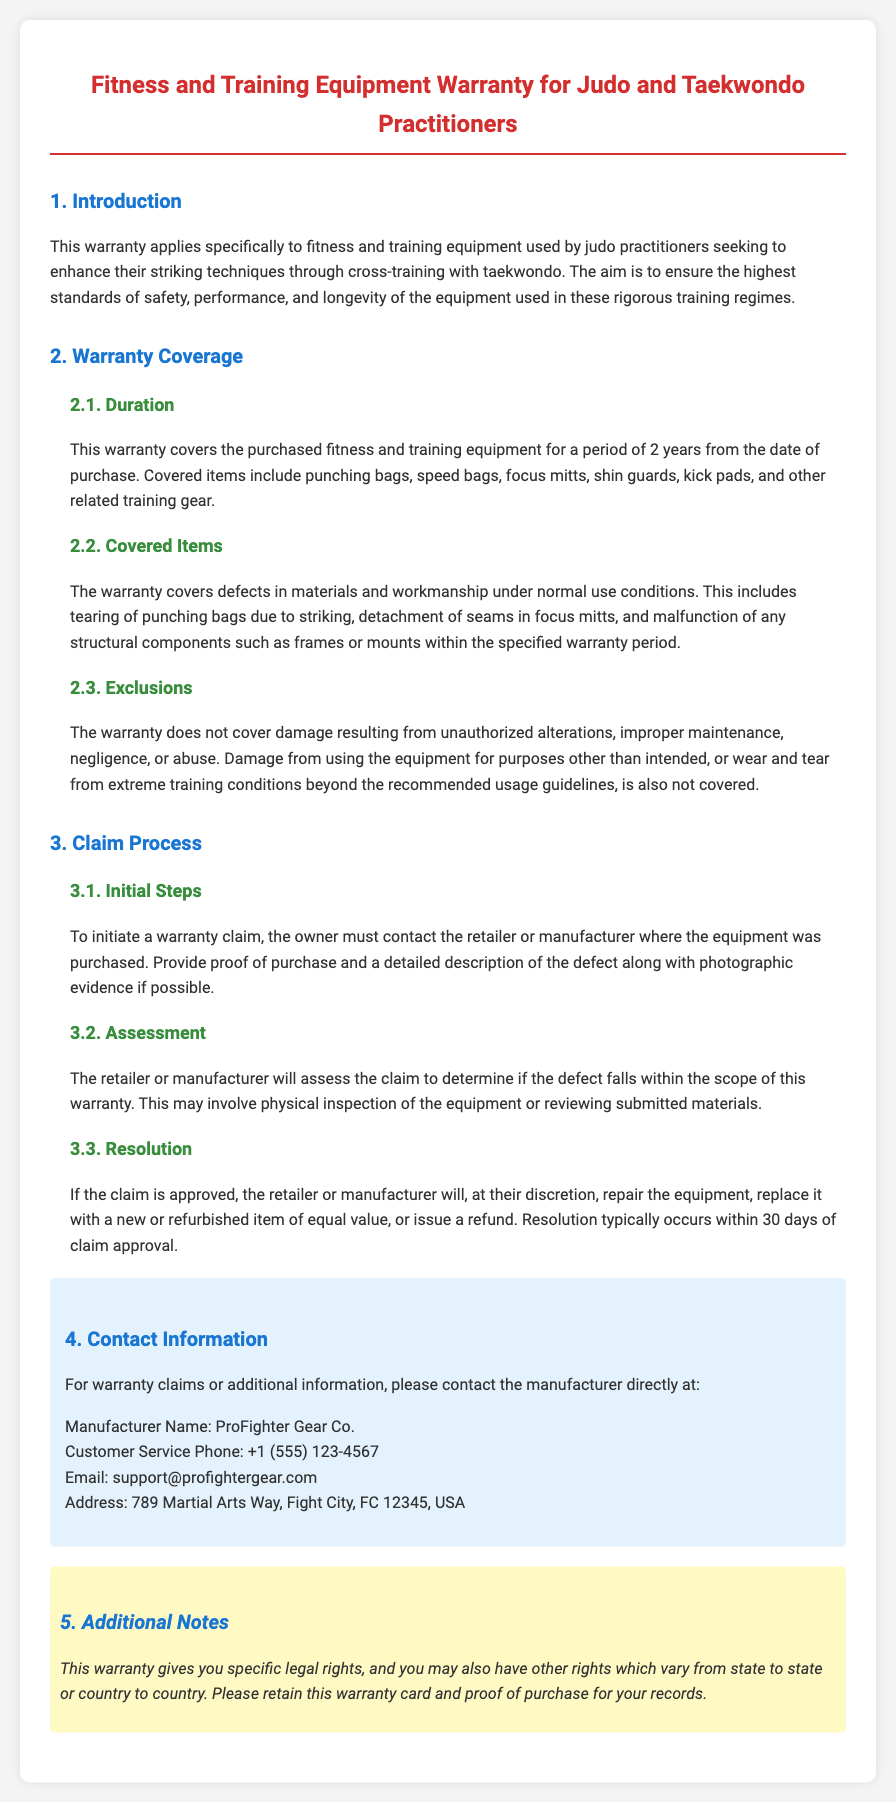What is the duration of the warranty? The warranty covers the purchased fitness and training equipment for a period of 2 years from the date of purchase.
Answer: 2 years Which items are covered under the warranty? The warranty covers defects in materials and workmanship of items such as punching bags, speed bags, focus mitts, and shin guards.
Answer: Punching bags, speed bags, focus mitts, shin guards What are the exclusions of the warranty? The warranty does not cover damage resulting from unauthorized alterations, improper maintenance, negligence, or abuse.
Answer: Unauthorized alterations, improper maintenance, negligence, abuse What is the first step to initiate a warranty claim? To initiate a warranty claim, the owner must contact the retailer or manufacturer where the equipment was purchased.
Answer: Contact the retailer or manufacturer Who is the manufacturer of the equipment? The document specifies the manufacturer responsible for the warranty claims.
Answer: ProFighter Gear Co How long does it typically take to resolve a claim? Resolution typically occurs within 30 days of claim approval.
Answer: 30 days What is required to provide for a warranty claim? The owner must provide proof of purchase and a detailed description of the defect along with photographic evidence if possible.
Answer: Proof of purchase and description of defect Can this warranty vary by location? The additional notes mention that this warranty gives you specific legal rights, which may vary from state to state or country to country.
Answer: Yes, it may vary by location What type of damage is not covered under the warranty? Damage from using the equipment for purposes other than intended, or wear and tear from extreme training conditions is not covered.
Answer: Damage from improper use and extreme wear 